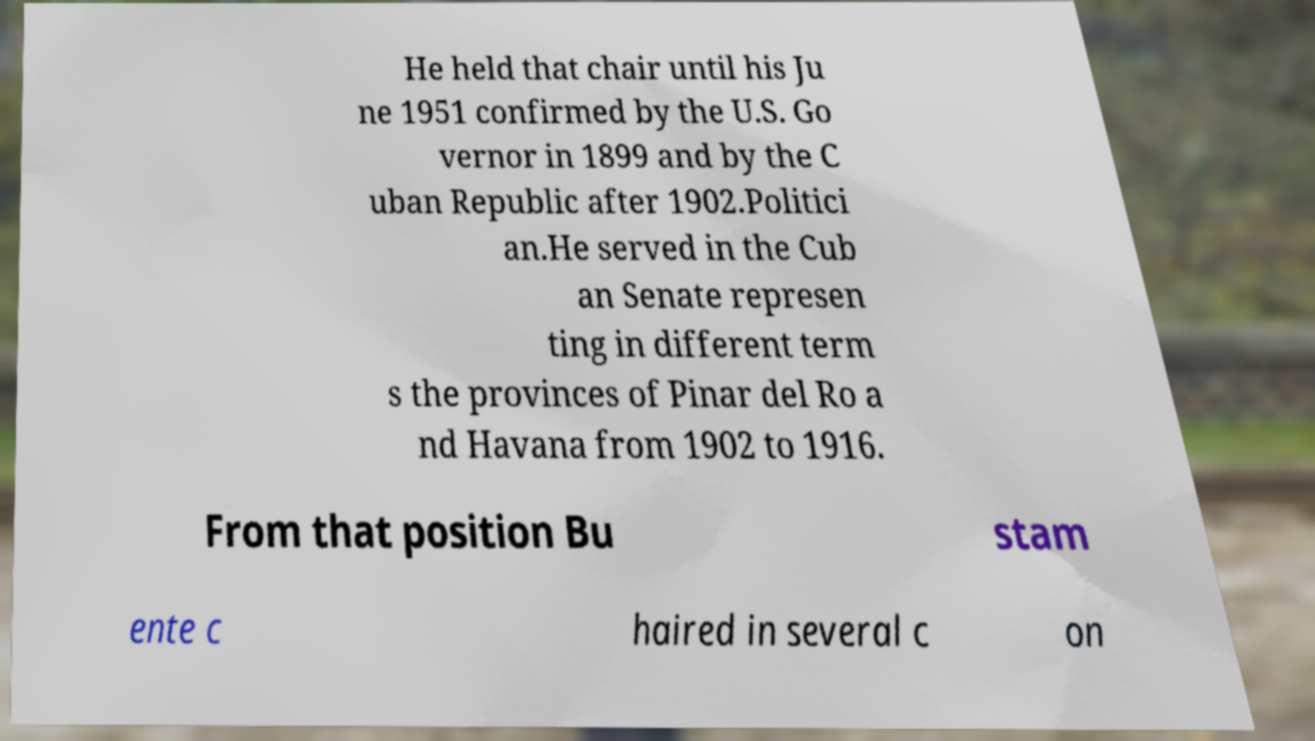There's text embedded in this image that I need extracted. Can you transcribe it verbatim? He held that chair until his Ju ne 1951 confirmed by the U.S. Go vernor in 1899 and by the C uban Republic after 1902.Politici an.He served in the Cub an Senate represen ting in different term s the provinces of Pinar del Ro a nd Havana from 1902 to 1916. From that position Bu stam ente c haired in several c on 